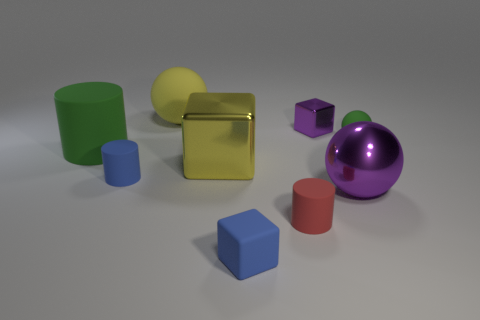Add 1 yellow objects. How many objects exist? 10 Subtract all balls. How many objects are left? 6 Add 3 big matte things. How many big matte things are left? 5 Add 9 gray rubber cubes. How many gray rubber cubes exist? 9 Subtract 0 cyan cylinders. How many objects are left? 9 Subtract all tiny rubber balls. Subtract all blocks. How many objects are left? 5 